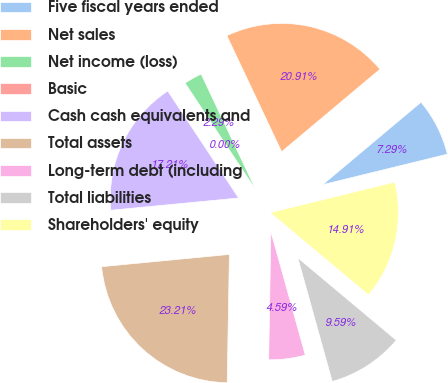<chart> <loc_0><loc_0><loc_500><loc_500><pie_chart><fcel>Five fiscal years ended<fcel>Net sales<fcel>Net income (loss)<fcel>Basic<fcel>Cash cash equivalents and<fcel>Total assets<fcel>Long-term debt (including<fcel>Total liabilities<fcel>Shareholders' equity<nl><fcel>7.29%<fcel>20.91%<fcel>2.29%<fcel>0.0%<fcel>17.21%<fcel>23.21%<fcel>4.59%<fcel>9.59%<fcel>14.91%<nl></chart> 